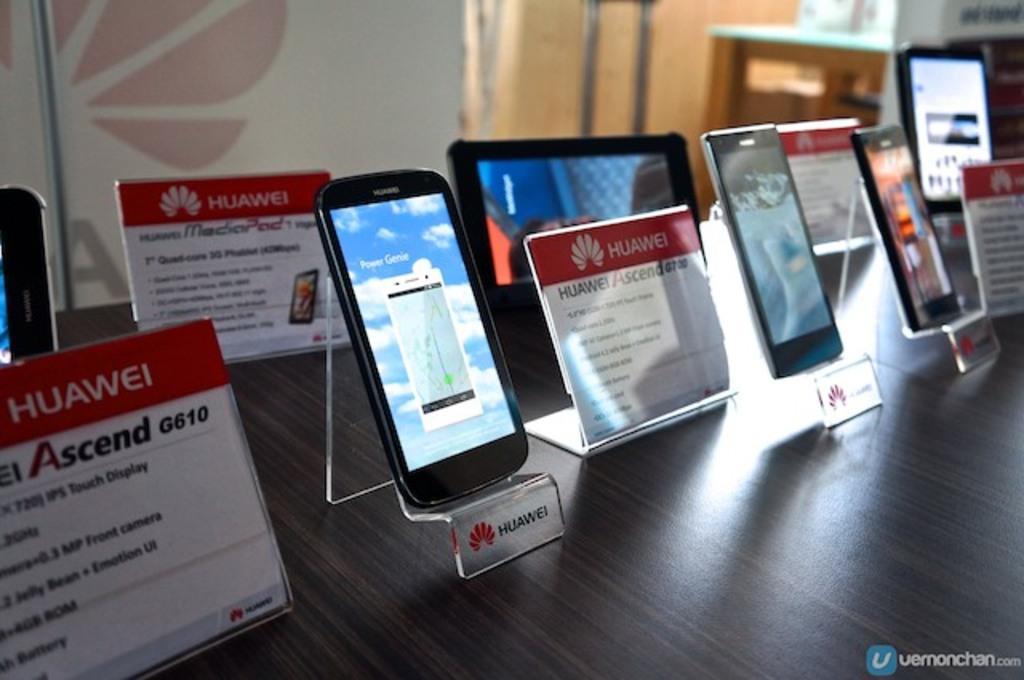<image>
Summarize the visual content of the image. a sign that has the word Huawei on it 